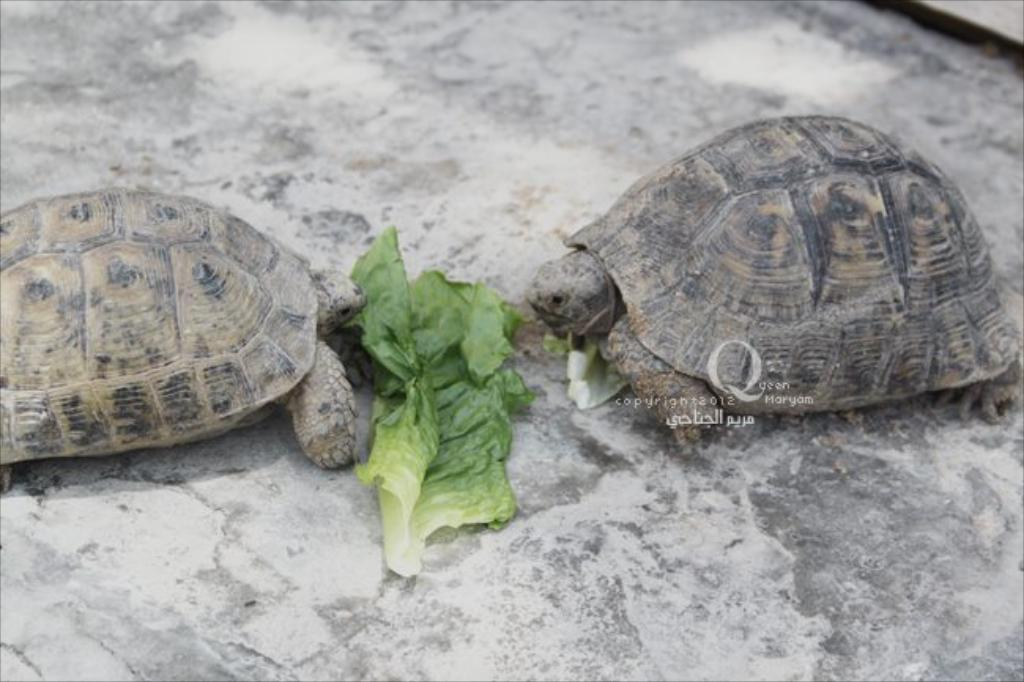What type of animals are in the image? There are tortoises in the image. Where are the tortoises located? The tortoises are on a surface. What can be seen between the tortoises? There are leaves in between the tortoises. What type of sticks can be seen being used by the tortoises in the image? There are no sticks present in the image; it only features tortoises and leaves. 